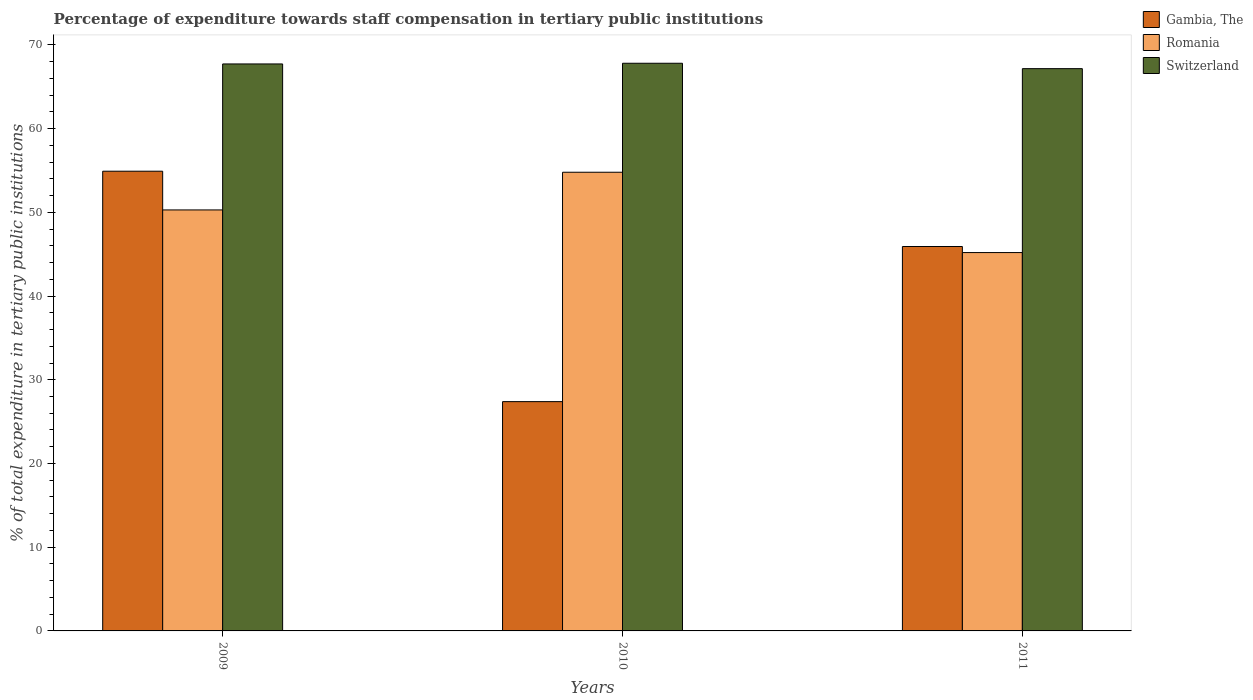How many different coloured bars are there?
Offer a terse response. 3. How many groups of bars are there?
Keep it short and to the point. 3. Are the number of bars on each tick of the X-axis equal?
Offer a terse response. Yes. What is the label of the 1st group of bars from the left?
Give a very brief answer. 2009. In how many cases, is the number of bars for a given year not equal to the number of legend labels?
Offer a very short reply. 0. What is the percentage of expenditure towards staff compensation in Switzerland in 2010?
Offer a terse response. 67.81. Across all years, what is the maximum percentage of expenditure towards staff compensation in Switzerland?
Give a very brief answer. 67.81. Across all years, what is the minimum percentage of expenditure towards staff compensation in Switzerland?
Offer a very short reply. 67.16. What is the total percentage of expenditure towards staff compensation in Romania in the graph?
Your response must be concise. 150.27. What is the difference between the percentage of expenditure towards staff compensation in Romania in 2009 and that in 2011?
Ensure brevity in your answer.  5.09. What is the difference between the percentage of expenditure towards staff compensation in Switzerland in 2011 and the percentage of expenditure towards staff compensation in Gambia, The in 2010?
Your answer should be very brief. 39.78. What is the average percentage of expenditure towards staff compensation in Switzerland per year?
Offer a very short reply. 67.57. In the year 2010, what is the difference between the percentage of expenditure towards staff compensation in Romania and percentage of expenditure towards staff compensation in Switzerland?
Offer a terse response. -13.02. What is the ratio of the percentage of expenditure towards staff compensation in Romania in 2010 to that in 2011?
Ensure brevity in your answer.  1.21. What is the difference between the highest and the second highest percentage of expenditure towards staff compensation in Gambia, The?
Your response must be concise. 8.99. What is the difference between the highest and the lowest percentage of expenditure towards staff compensation in Romania?
Provide a short and direct response. 9.6. In how many years, is the percentage of expenditure towards staff compensation in Gambia, The greater than the average percentage of expenditure towards staff compensation in Gambia, The taken over all years?
Give a very brief answer. 2. Is the sum of the percentage of expenditure towards staff compensation in Switzerland in 2009 and 2010 greater than the maximum percentage of expenditure towards staff compensation in Gambia, The across all years?
Provide a succinct answer. Yes. What does the 2nd bar from the left in 2010 represents?
Offer a very short reply. Romania. What does the 2nd bar from the right in 2010 represents?
Keep it short and to the point. Romania. How many bars are there?
Your answer should be compact. 9. Are the values on the major ticks of Y-axis written in scientific E-notation?
Keep it short and to the point. No. What is the title of the graph?
Offer a terse response. Percentage of expenditure towards staff compensation in tertiary public institutions. Does "Macao" appear as one of the legend labels in the graph?
Offer a very short reply. No. What is the label or title of the Y-axis?
Provide a short and direct response. % of total expenditure in tertiary public institutions. What is the % of total expenditure in tertiary public institutions in Gambia, The in 2009?
Offer a very short reply. 54.91. What is the % of total expenditure in tertiary public institutions of Romania in 2009?
Give a very brief answer. 50.29. What is the % of total expenditure in tertiary public institutions in Switzerland in 2009?
Provide a short and direct response. 67.73. What is the % of total expenditure in tertiary public institutions in Gambia, The in 2010?
Ensure brevity in your answer.  27.39. What is the % of total expenditure in tertiary public institutions in Romania in 2010?
Offer a very short reply. 54.79. What is the % of total expenditure in tertiary public institutions of Switzerland in 2010?
Keep it short and to the point. 67.81. What is the % of total expenditure in tertiary public institutions in Gambia, The in 2011?
Provide a succinct answer. 45.92. What is the % of total expenditure in tertiary public institutions of Romania in 2011?
Provide a short and direct response. 45.19. What is the % of total expenditure in tertiary public institutions of Switzerland in 2011?
Provide a short and direct response. 67.16. Across all years, what is the maximum % of total expenditure in tertiary public institutions of Gambia, The?
Provide a short and direct response. 54.91. Across all years, what is the maximum % of total expenditure in tertiary public institutions of Romania?
Your answer should be very brief. 54.79. Across all years, what is the maximum % of total expenditure in tertiary public institutions in Switzerland?
Ensure brevity in your answer.  67.81. Across all years, what is the minimum % of total expenditure in tertiary public institutions of Gambia, The?
Offer a terse response. 27.39. Across all years, what is the minimum % of total expenditure in tertiary public institutions of Romania?
Your answer should be compact. 45.19. Across all years, what is the minimum % of total expenditure in tertiary public institutions in Switzerland?
Keep it short and to the point. 67.16. What is the total % of total expenditure in tertiary public institutions in Gambia, The in the graph?
Offer a terse response. 128.22. What is the total % of total expenditure in tertiary public institutions in Romania in the graph?
Your response must be concise. 150.27. What is the total % of total expenditure in tertiary public institutions in Switzerland in the graph?
Keep it short and to the point. 202.7. What is the difference between the % of total expenditure in tertiary public institutions in Gambia, The in 2009 and that in 2010?
Give a very brief answer. 27.52. What is the difference between the % of total expenditure in tertiary public institutions in Romania in 2009 and that in 2010?
Your answer should be very brief. -4.5. What is the difference between the % of total expenditure in tertiary public institutions in Switzerland in 2009 and that in 2010?
Ensure brevity in your answer.  -0.08. What is the difference between the % of total expenditure in tertiary public institutions of Gambia, The in 2009 and that in 2011?
Make the answer very short. 8.99. What is the difference between the % of total expenditure in tertiary public institutions of Romania in 2009 and that in 2011?
Offer a terse response. 5.09. What is the difference between the % of total expenditure in tertiary public institutions of Switzerland in 2009 and that in 2011?
Provide a short and direct response. 0.56. What is the difference between the % of total expenditure in tertiary public institutions of Gambia, The in 2010 and that in 2011?
Make the answer very short. -18.53. What is the difference between the % of total expenditure in tertiary public institutions of Romania in 2010 and that in 2011?
Offer a terse response. 9.6. What is the difference between the % of total expenditure in tertiary public institutions of Switzerland in 2010 and that in 2011?
Offer a very short reply. 0.64. What is the difference between the % of total expenditure in tertiary public institutions of Gambia, The in 2009 and the % of total expenditure in tertiary public institutions of Romania in 2010?
Ensure brevity in your answer.  0.12. What is the difference between the % of total expenditure in tertiary public institutions in Gambia, The in 2009 and the % of total expenditure in tertiary public institutions in Switzerland in 2010?
Make the answer very short. -12.9. What is the difference between the % of total expenditure in tertiary public institutions of Romania in 2009 and the % of total expenditure in tertiary public institutions of Switzerland in 2010?
Keep it short and to the point. -17.52. What is the difference between the % of total expenditure in tertiary public institutions in Gambia, The in 2009 and the % of total expenditure in tertiary public institutions in Romania in 2011?
Keep it short and to the point. 9.72. What is the difference between the % of total expenditure in tertiary public institutions of Gambia, The in 2009 and the % of total expenditure in tertiary public institutions of Switzerland in 2011?
Offer a terse response. -12.25. What is the difference between the % of total expenditure in tertiary public institutions in Romania in 2009 and the % of total expenditure in tertiary public institutions in Switzerland in 2011?
Your response must be concise. -16.88. What is the difference between the % of total expenditure in tertiary public institutions in Gambia, The in 2010 and the % of total expenditure in tertiary public institutions in Romania in 2011?
Your answer should be very brief. -17.8. What is the difference between the % of total expenditure in tertiary public institutions of Gambia, The in 2010 and the % of total expenditure in tertiary public institutions of Switzerland in 2011?
Give a very brief answer. -39.78. What is the difference between the % of total expenditure in tertiary public institutions of Romania in 2010 and the % of total expenditure in tertiary public institutions of Switzerland in 2011?
Ensure brevity in your answer.  -12.37. What is the average % of total expenditure in tertiary public institutions of Gambia, The per year?
Your answer should be compact. 42.74. What is the average % of total expenditure in tertiary public institutions in Romania per year?
Your answer should be compact. 50.09. What is the average % of total expenditure in tertiary public institutions in Switzerland per year?
Give a very brief answer. 67.57. In the year 2009, what is the difference between the % of total expenditure in tertiary public institutions of Gambia, The and % of total expenditure in tertiary public institutions of Romania?
Make the answer very short. 4.62. In the year 2009, what is the difference between the % of total expenditure in tertiary public institutions in Gambia, The and % of total expenditure in tertiary public institutions in Switzerland?
Offer a terse response. -12.81. In the year 2009, what is the difference between the % of total expenditure in tertiary public institutions in Romania and % of total expenditure in tertiary public institutions in Switzerland?
Keep it short and to the point. -17.44. In the year 2010, what is the difference between the % of total expenditure in tertiary public institutions of Gambia, The and % of total expenditure in tertiary public institutions of Romania?
Your answer should be very brief. -27.4. In the year 2010, what is the difference between the % of total expenditure in tertiary public institutions of Gambia, The and % of total expenditure in tertiary public institutions of Switzerland?
Provide a short and direct response. -40.42. In the year 2010, what is the difference between the % of total expenditure in tertiary public institutions in Romania and % of total expenditure in tertiary public institutions in Switzerland?
Provide a short and direct response. -13.02. In the year 2011, what is the difference between the % of total expenditure in tertiary public institutions of Gambia, The and % of total expenditure in tertiary public institutions of Romania?
Offer a very short reply. 0.72. In the year 2011, what is the difference between the % of total expenditure in tertiary public institutions in Gambia, The and % of total expenditure in tertiary public institutions in Switzerland?
Keep it short and to the point. -21.25. In the year 2011, what is the difference between the % of total expenditure in tertiary public institutions of Romania and % of total expenditure in tertiary public institutions of Switzerland?
Offer a very short reply. -21.97. What is the ratio of the % of total expenditure in tertiary public institutions in Gambia, The in 2009 to that in 2010?
Your answer should be compact. 2. What is the ratio of the % of total expenditure in tertiary public institutions in Romania in 2009 to that in 2010?
Offer a very short reply. 0.92. What is the ratio of the % of total expenditure in tertiary public institutions of Switzerland in 2009 to that in 2010?
Keep it short and to the point. 1. What is the ratio of the % of total expenditure in tertiary public institutions in Gambia, The in 2009 to that in 2011?
Ensure brevity in your answer.  1.2. What is the ratio of the % of total expenditure in tertiary public institutions of Romania in 2009 to that in 2011?
Your response must be concise. 1.11. What is the ratio of the % of total expenditure in tertiary public institutions in Switzerland in 2009 to that in 2011?
Provide a short and direct response. 1.01. What is the ratio of the % of total expenditure in tertiary public institutions in Gambia, The in 2010 to that in 2011?
Offer a terse response. 0.6. What is the ratio of the % of total expenditure in tertiary public institutions in Romania in 2010 to that in 2011?
Ensure brevity in your answer.  1.21. What is the ratio of the % of total expenditure in tertiary public institutions in Switzerland in 2010 to that in 2011?
Your response must be concise. 1.01. What is the difference between the highest and the second highest % of total expenditure in tertiary public institutions in Gambia, The?
Give a very brief answer. 8.99. What is the difference between the highest and the second highest % of total expenditure in tertiary public institutions of Romania?
Offer a very short reply. 4.5. What is the difference between the highest and the second highest % of total expenditure in tertiary public institutions of Switzerland?
Give a very brief answer. 0.08. What is the difference between the highest and the lowest % of total expenditure in tertiary public institutions of Gambia, The?
Keep it short and to the point. 27.52. What is the difference between the highest and the lowest % of total expenditure in tertiary public institutions in Romania?
Your answer should be very brief. 9.6. What is the difference between the highest and the lowest % of total expenditure in tertiary public institutions of Switzerland?
Offer a very short reply. 0.64. 